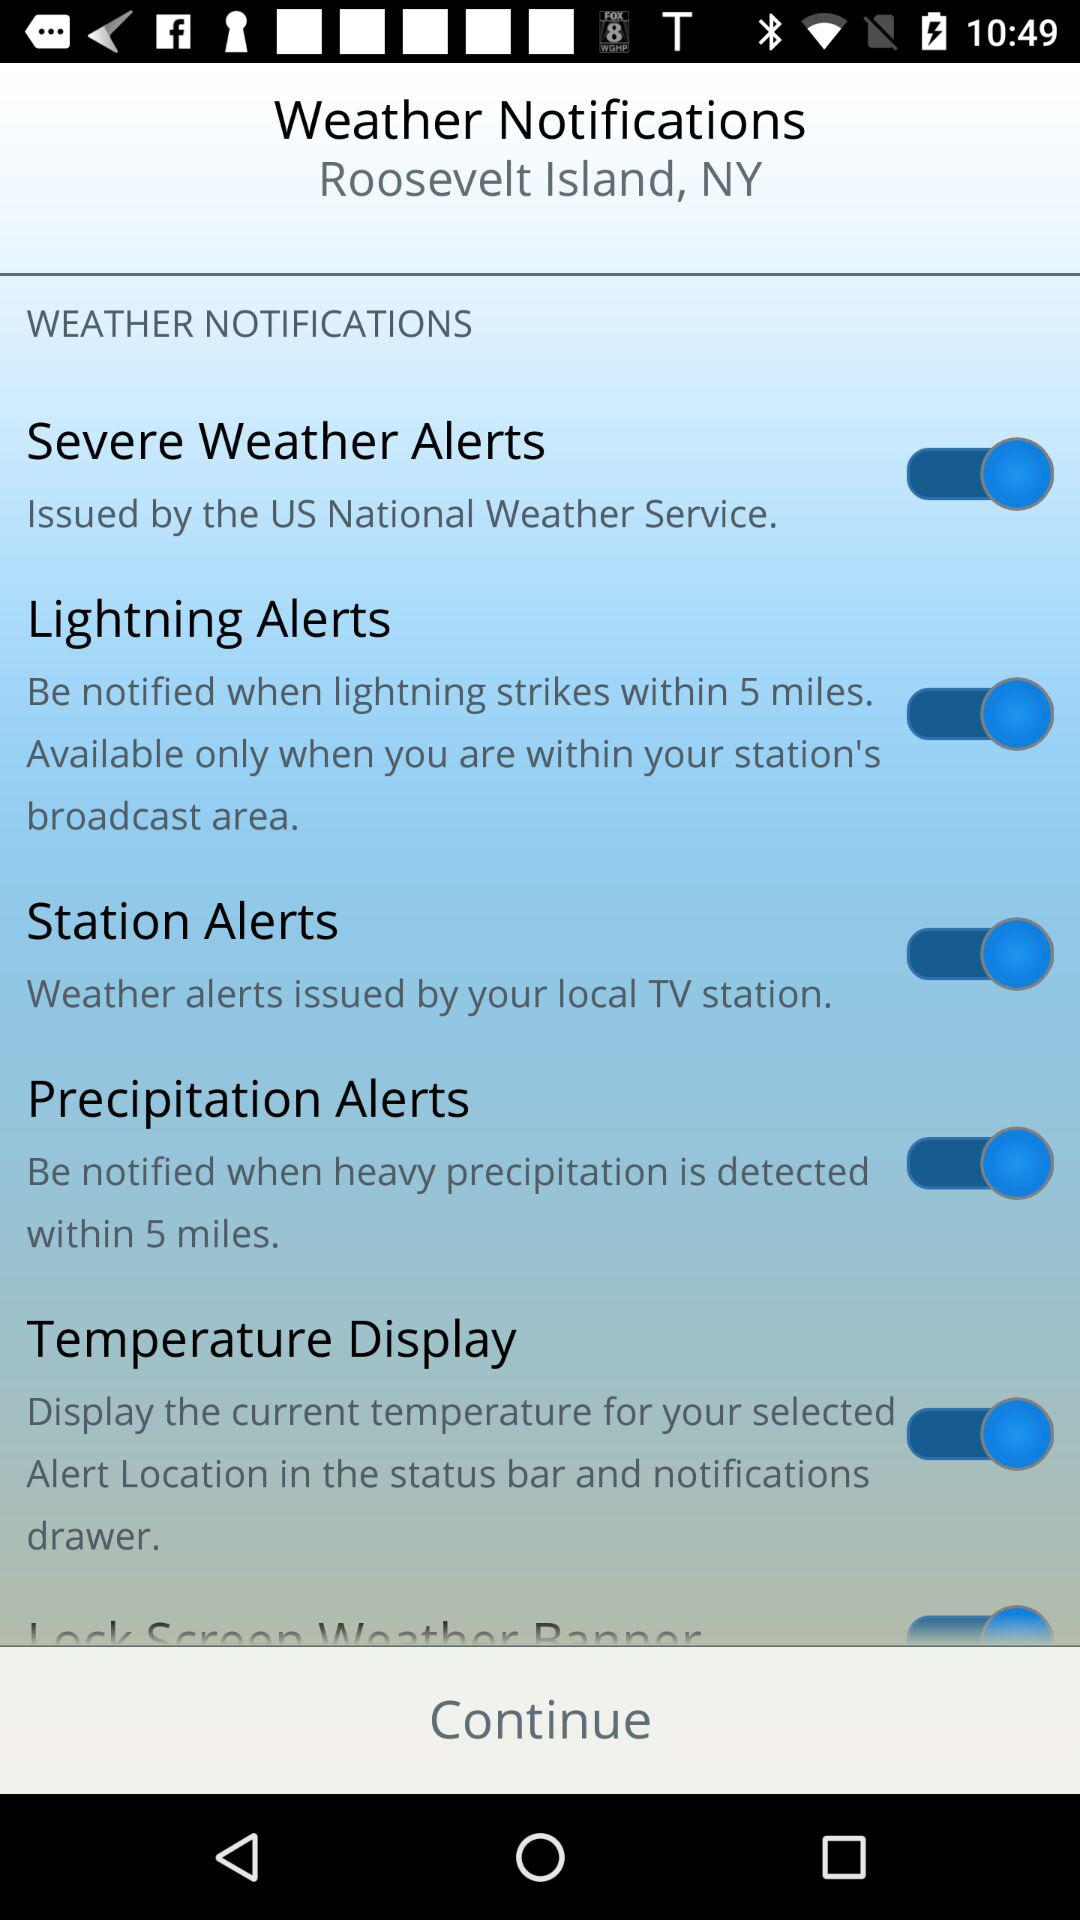What is the status of the "Station Alerts" notification setting? The status is "on". 